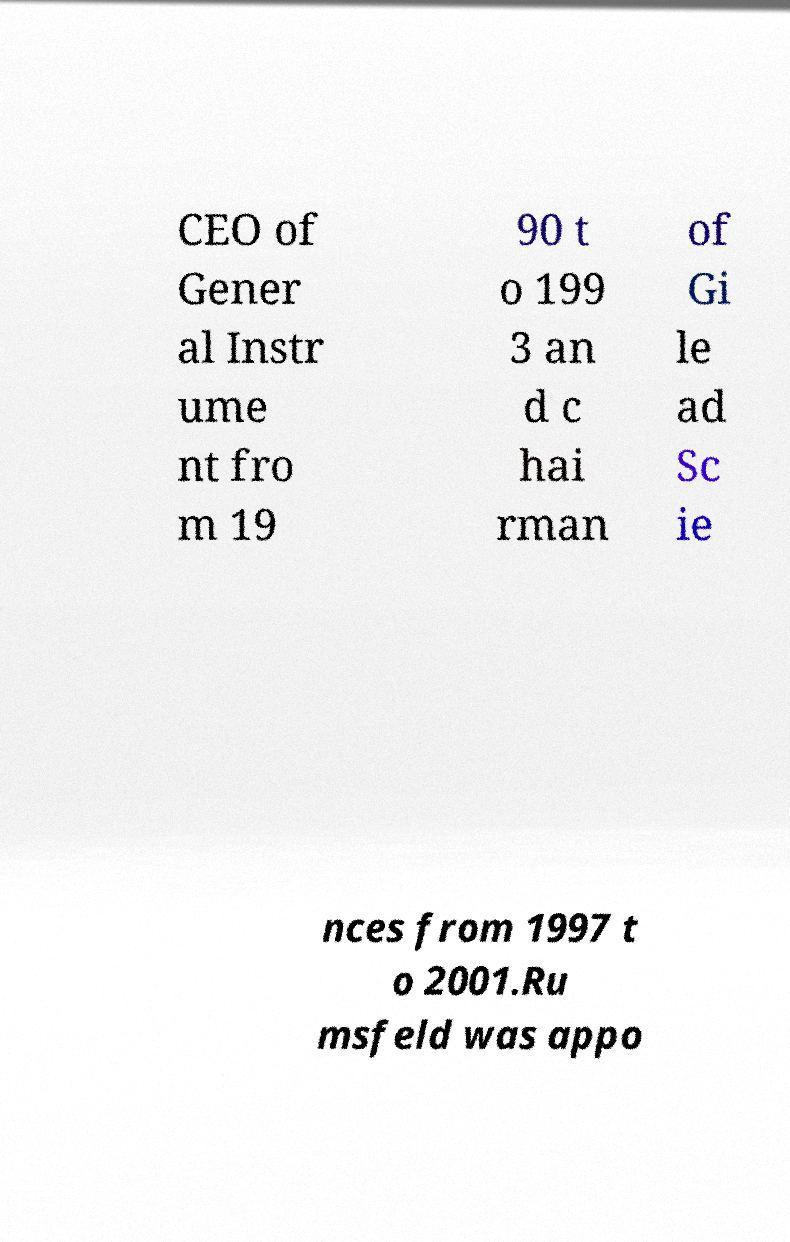Please read and relay the text visible in this image. What does it say? CEO of Gener al Instr ume nt fro m 19 90 t o 199 3 an d c hai rman of Gi le ad Sc ie nces from 1997 t o 2001.Ru msfeld was appo 